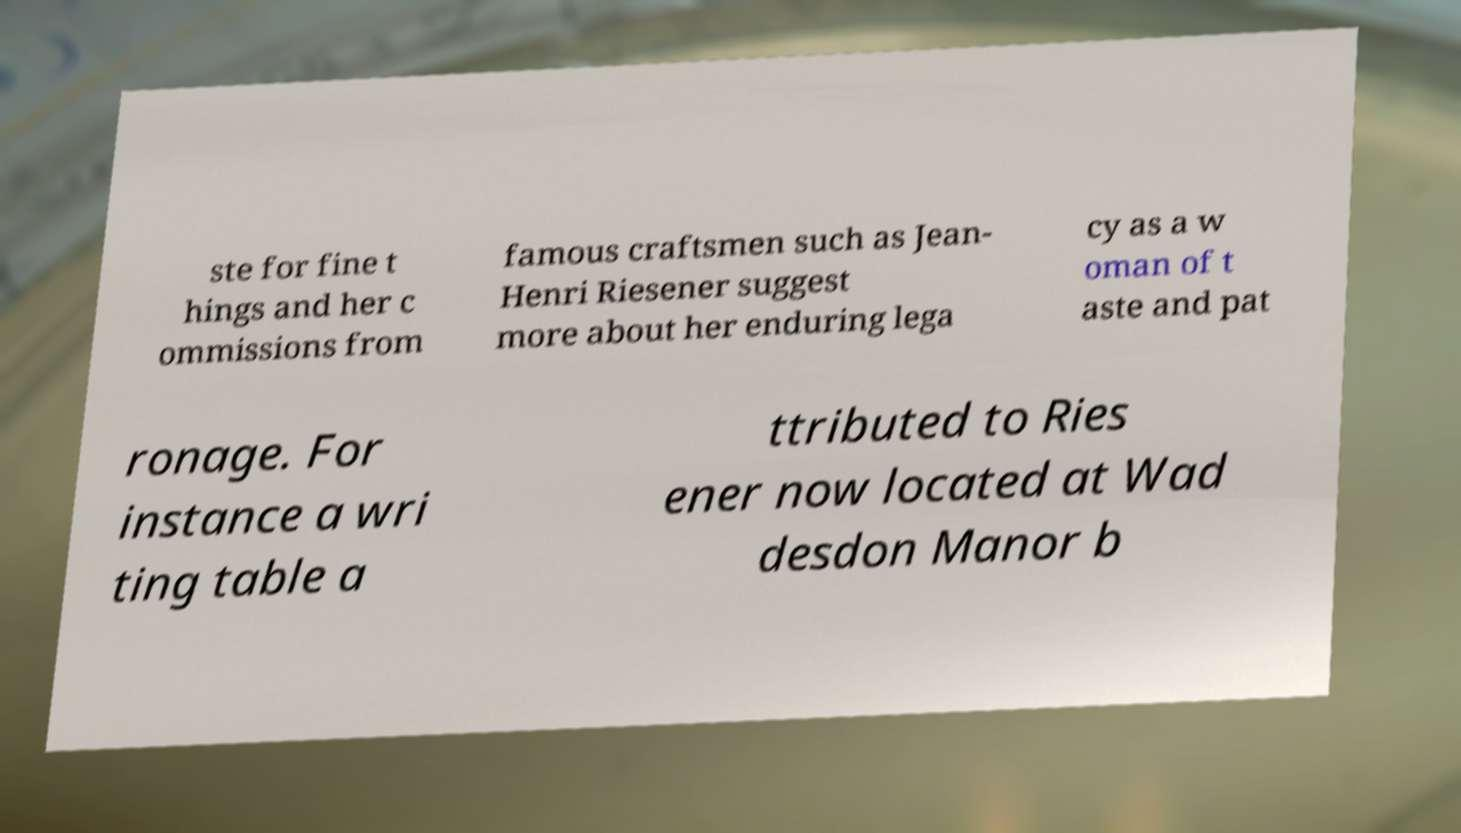Can you accurately transcribe the text from the provided image for me? ste for fine t hings and her c ommissions from famous craftsmen such as Jean- Henri Riesener suggest more about her enduring lega cy as a w oman of t aste and pat ronage. For instance a wri ting table a ttributed to Ries ener now located at Wad desdon Manor b 